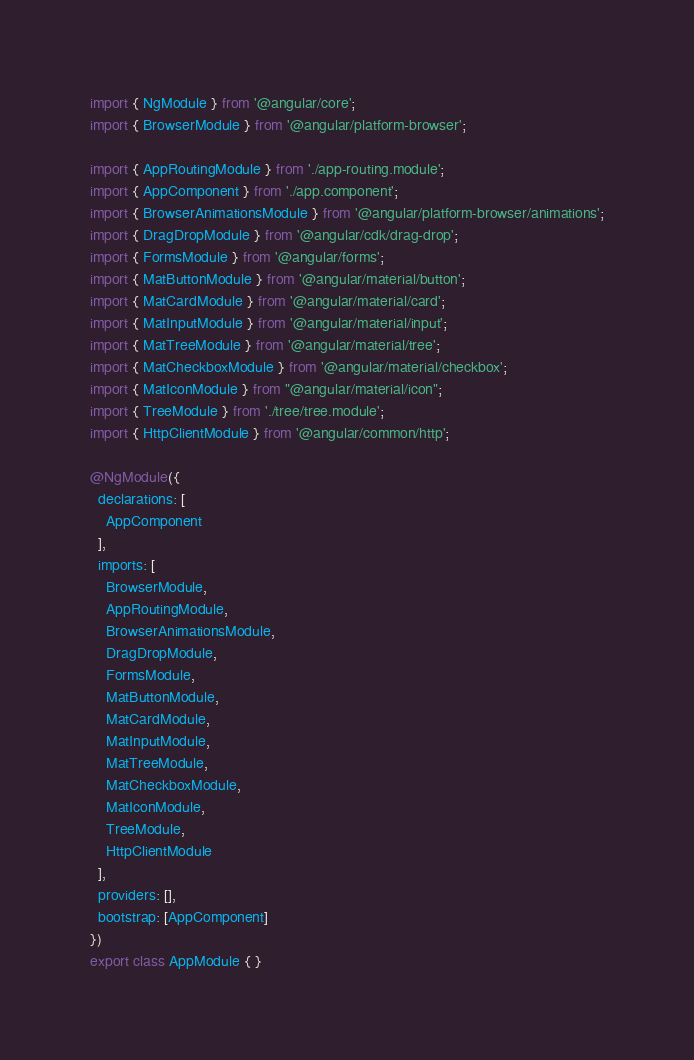<code> <loc_0><loc_0><loc_500><loc_500><_TypeScript_>import { NgModule } from '@angular/core';
import { BrowserModule } from '@angular/platform-browser';

import { AppRoutingModule } from './app-routing.module';
import { AppComponent } from './app.component';
import { BrowserAnimationsModule } from '@angular/platform-browser/animations';
import { DragDropModule } from '@angular/cdk/drag-drop';
import { FormsModule } from '@angular/forms';
import { MatButtonModule } from '@angular/material/button';
import { MatCardModule } from '@angular/material/card';
import { MatInputModule } from '@angular/material/input';
import { MatTreeModule } from '@angular/material/tree';
import { MatCheckboxModule } from '@angular/material/checkbox';
import { MatIconModule } from "@angular/material/icon";
import { TreeModule } from './tree/tree.module';
import { HttpClientModule } from '@angular/common/http';

@NgModule({
  declarations: [
    AppComponent
  ],
  imports: [
    BrowserModule,
    AppRoutingModule,
    BrowserAnimationsModule,
    DragDropModule,
    FormsModule,
    MatButtonModule,
    MatCardModule,
    MatInputModule,
    MatTreeModule,
    MatCheckboxModule,
    MatIconModule,
    TreeModule,
    HttpClientModule
  ],
  providers: [],
  bootstrap: [AppComponent]
})
export class AppModule { }
</code> 